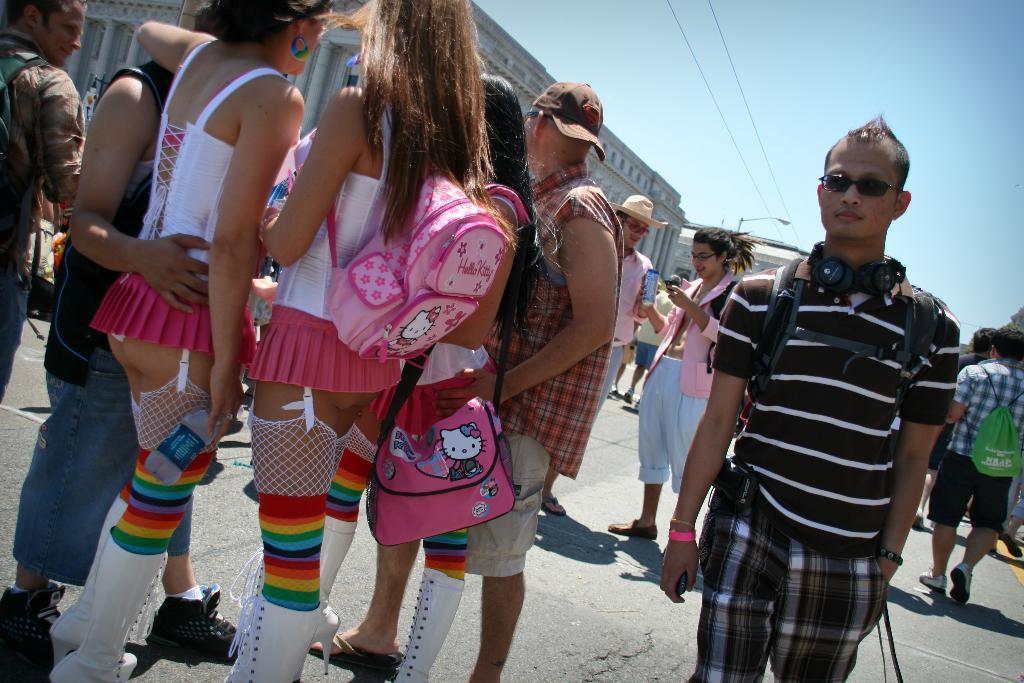Please provide a concise description of this image. In this image I can see group of people standing. In front the person is wearing black and white color dress. In the background I can see few buildings in white color and the sky is in blue and white color. 